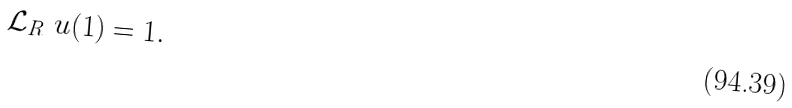Convert formula to latex. <formula><loc_0><loc_0><loc_500><loc_500>\mathcal { L } _ { R } \ u ( 1 ) = 1 .</formula> 